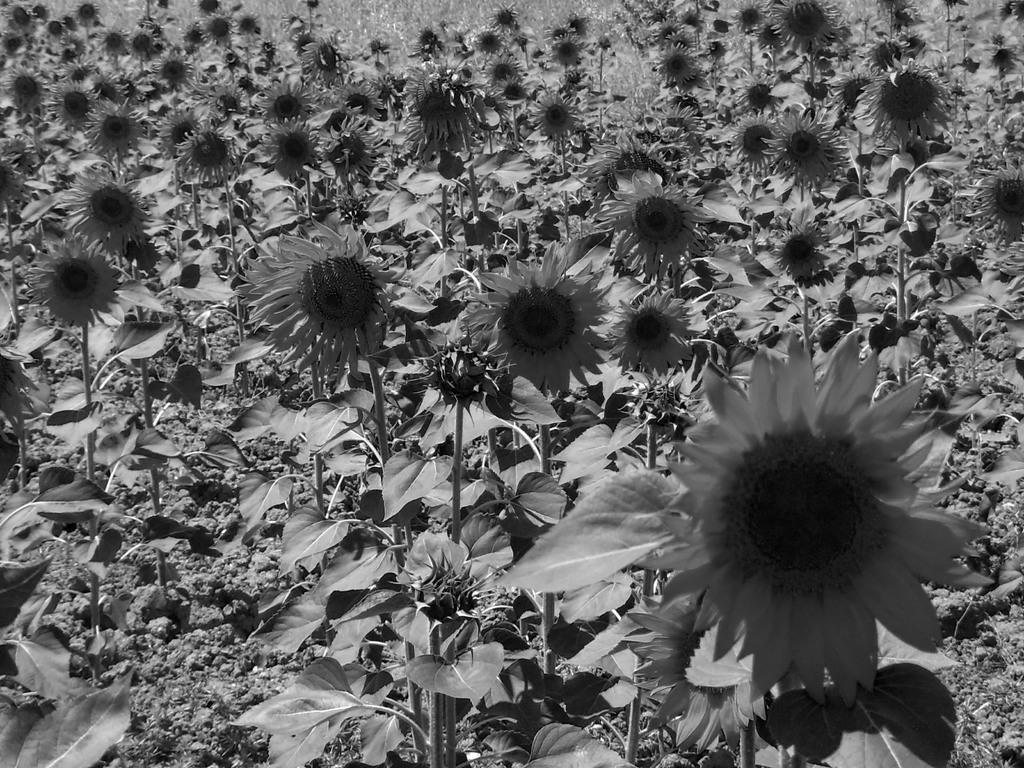In one or two sentences, can you explain what this image depicts? In this image I can see few flowers and leaves and the image is in black and white. 